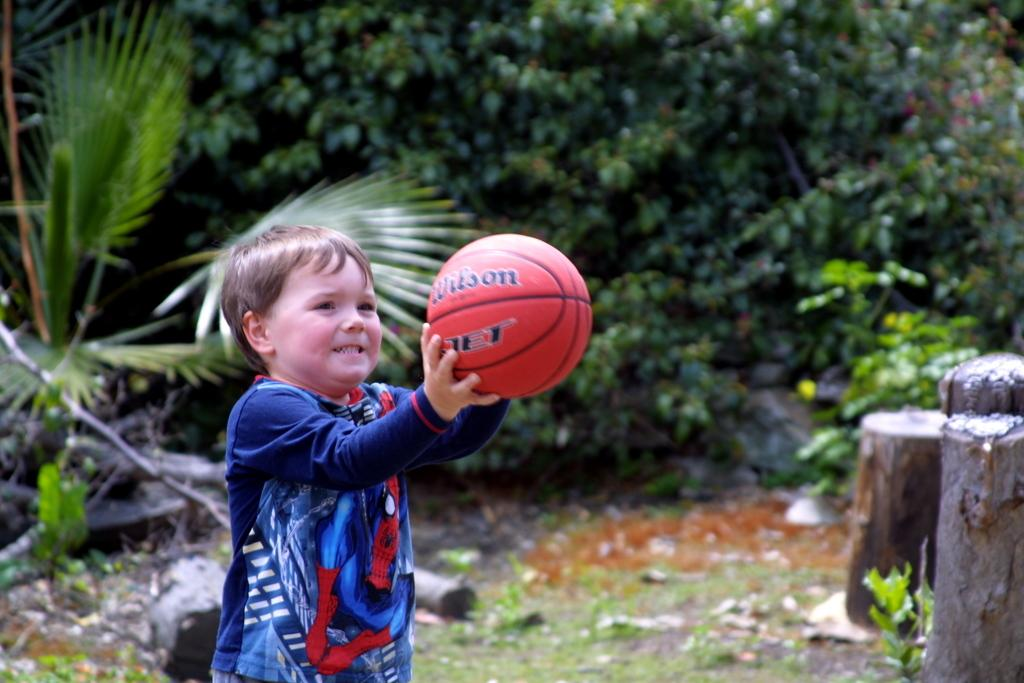Who is the main subject in the image? There is a boy in the image. What is the boy holding in the image? The boy is holding a ball. What is the boy wearing in the image? The boy is wearing a blue t-shirt. What can be seen in the background of the image? There are trees in the background of the image. What type of industry can be seen in the background of the image? There is no industry present in the image; it features a boy holding a ball and wearing a blue t-shirt, with trees in the background. 